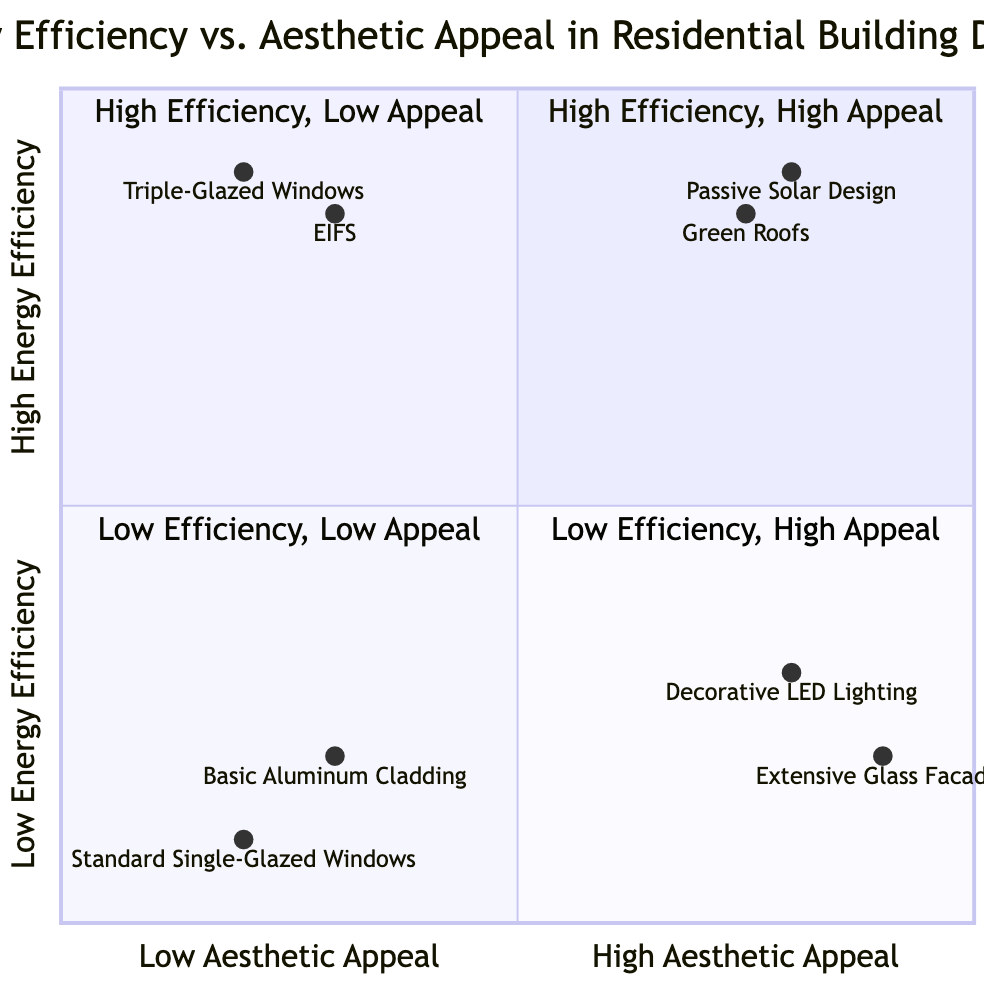What is positioned in Quadrant 1? Quadrant 1 represents "High Energy Efficiency & High Aesthetic Appeal," which includes Passive Solar Design and Green Roofs.
Answer: Passive Solar Design, Green Roofs How many items are in Quadrant 4? Quadrant 4 denotes "Low Energy Efficiency & High Aesthetic Appeal." There are two items listed in this quadrant: Extensive Glass Facades and Decorative LED Lighting.
Answer: 2 Which design option has the highest energy efficiency? Identifying the items in Quadrant 1, Passive Solar Design has the highest y-axis value of 0.9, which indicates its high energy efficiency.
Answer: Passive Solar Design What is the aesthetic appeal value of Triple-Glazed Windows? Triple-Glazed Windows are located in Quadrant 2, and their aesthetic appeal value is represented as 0.9 on the x-axis.
Answer: 0.9 Identify the design with the lowest energy efficiency in the chart. In reviewing the quadrants, Standard Single-Glazed Windows has the lowest y-axis value of 0.1, indicating it offers the least energy efficiency.
Answer: Standard Single-Glazed Windows Which quadrant contains designs with low aesthetic appeal? Quadrant 2, which is "High Energy Efficiency & Low Aesthetic Appeal," and Quadrant 3, which is "Low Energy Efficiency & Low Aesthetic Appeal," both contain designs with low aesthetic appeal.
Answer: Quadrant 2, Quadrant 3 What similarities exist between the items in Quadrant 3? The items, Standard Single-Glazed Windows and Basic Aluminum Cladding in Quadrant 3, share the characteristic of both low energy efficiency and low aesthetic appeal, positioning them together in this quadrant.
Answer: Low energy efficiency and low aesthetic appeal How does the energy efficiency of External Insulation Finishing Systems compare to that of Triple-Glazed Windows? External Insulation Finishing Systems, with a y-axis value of 0.85, is lower than Triple-Glazed Windows, which has a higher y-axis value of 0.9, indicating it has slightly better energy efficiency.
Answer: Triple-Glazed Windows What is the role of the x-axis in this diagram? The x-axis represents aesthetic appeal, ranging from low to high, allowing for the classification of design options based on their visual appeal.
Answer: Aesthetic appeal What design has the highest aesthetic appeal and low energy efficiency? Extensive Glass Facades in Quadrant 4 has a high aesthetic appeal score of 0.9 but a low energy efficiency of 0.2, making it the highest aesthetic appeal item in that category.
Answer: Extensive Glass Facades 